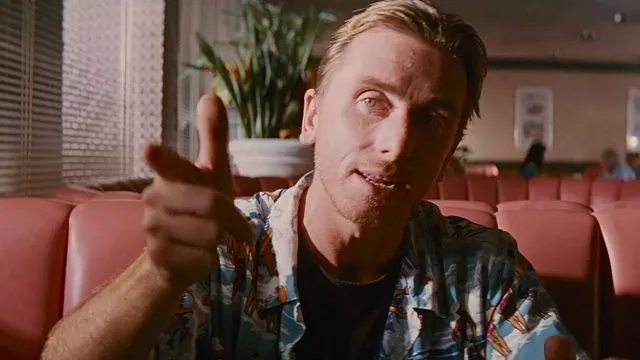Can you describe the main features of this image for me? The image features a person pointing directly towards the camera with a relaxed posture, seated in what appears to be a diner booth. The individual is dressed in a casual, patterned shirt with rolled-up sleeves, suggesting a laid-back or informal setting. The person's hair is slicked back, and there is a soft smile on their face, lending a friendly or approachable demeanor to the image. The background, though blurred, shows elements like another booth and a plant, indicating an indoor environment likely designed for casual dining. The lighting is soft and diffused, highlighting the person's features without harsh shadows. 